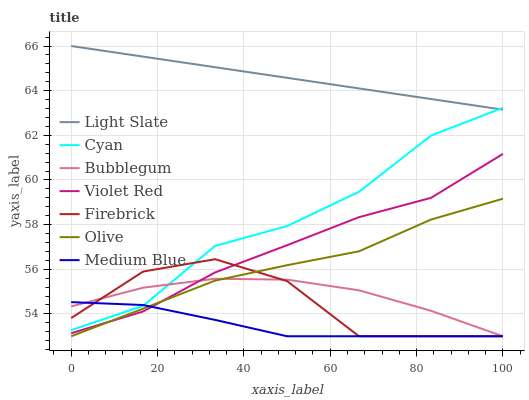Does Medium Blue have the minimum area under the curve?
Answer yes or no. Yes. Does Light Slate have the maximum area under the curve?
Answer yes or no. Yes. Does Firebrick have the minimum area under the curve?
Answer yes or no. No. Does Firebrick have the maximum area under the curve?
Answer yes or no. No. Is Light Slate the smoothest?
Answer yes or no. Yes. Is Firebrick the roughest?
Answer yes or no. Yes. Is Firebrick the smoothest?
Answer yes or no. No. Is Light Slate the roughest?
Answer yes or no. No. Does Firebrick have the lowest value?
Answer yes or no. Yes. Does Light Slate have the lowest value?
Answer yes or no. No. Does Light Slate have the highest value?
Answer yes or no. Yes. Does Firebrick have the highest value?
Answer yes or no. No. Is Olive less than Light Slate?
Answer yes or no. Yes. Is Light Slate greater than Medium Blue?
Answer yes or no. Yes. Does Bubblegum intersect Cyan?
Answer yes or no. Yes. Is Bubblegum less than Cyan?
Answer yes or no. No. Is Bubblegum greater than Cyan?
Answer yes or no. No. Does Olive intersect Light Slate?
Answer yes or no. No. 